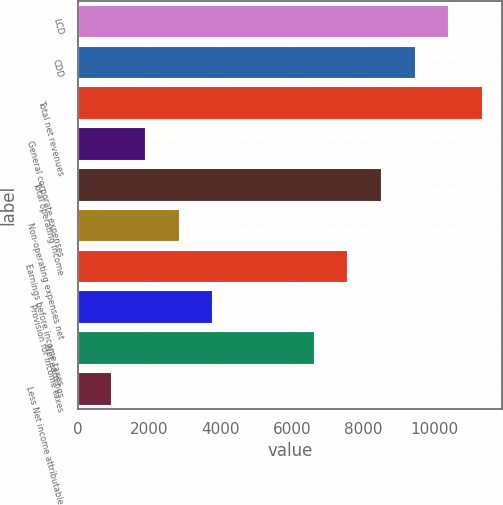<chart> <loc_0><loc_0><loc_500><loc_500><bar_chart><fcel>LCD<fcel>CDD<fcel>Total net revenues<fcel>General corporate expenses<fcel>Total operating income<fcel>Non-operating expenses net<fcel>Earnings before income taxes<fcel>Provision for income taxes<fcel>Net earnings<fcel>Less Net income attributable<nl><fcel>10380.9<fcel>9437.2<fcel>11324.6<fcel>1887.52<fcel>8493.49<fcel>2831.23<fcel>7549.78<fcel>3774.94<fcel>6606.07<fcel>943.81<nl></chart> 